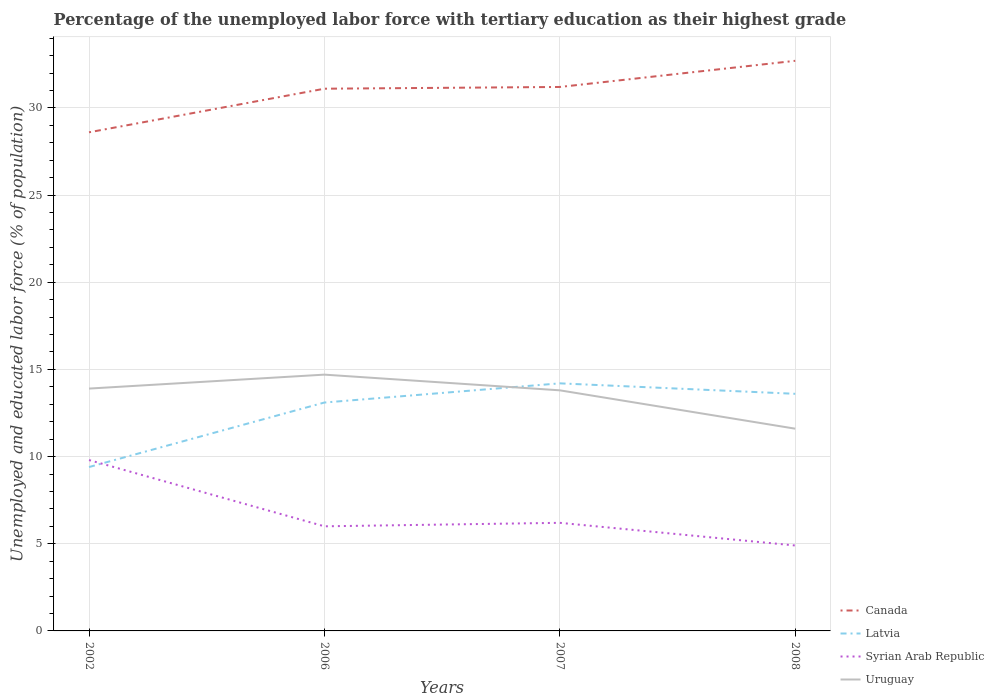How many different coloured lines are there?
Provide a short and direct response. 4. Across all years, what is the maximum percentage of the unemployed labor force with tertiary education in Latvia?
Ensure brevity in your answer.  9.4. What is the total percentage of the unemployed labor force with tertiary education in Canada in the graph?
Keep it short and to the point. -0.1. What is the difference between the highest and the second highest percentage of the unemployed labor force with tertiary education in Canada?
Your answer should be compact. 4.1. What is the difference between the highest and the lowest percentage of the unemployed labor force with tertiary education in Syrian Arab Republic?
Ensure brevity in your answer.  1. How many lines are there?
Offer a terse response. 4. How many years are there in the graph?
Offer a very short reply. 4. Are the values on the major ticks of Y-axis written in scientific E-notation?
Your response must be concise. No. Does the graph contain any zero values?
Offer a terse response. No. Where does the legend appear in the graph?
Your answer should be very brief. Bottom right. How many legend labels are there?
Provide a short and direct response. 4. How are the legend labels stacked?
Your response must be concise. Vertical. What is the title of the graph?
Give a very brief answer. Percentage of the unemployed labor force with tertiary education as their highest grade. Does "Micronesia" appear as one of the legend labels in the graph?
Your answer should be compact. No. What is the label or title of the Y-axis?
Provide a succinct answer. Unemployed and educated labor force (% of population). What is the Unemployed and educated labor force (% of population) in Canada in 2002?
Provide a short and direct response. 28.6. What is the Unemployed and educated labor force (% of population) in Latvia in 2002?
Offer a very short reply. 9.4. What is the Unemployed and educated labor force (% of population) in Syrian Arab Republic in 2002?
Provide a short and direct response. 9.8. What is the Unemployed and educated labor force (% of population) in Uruguay in 2002?
Your answer should be compact. 13.9. What is the Unemployed and educated labor force (% of population) of Canada in 2006?
Your answer should be very brief. 31.1. What is the Unemployed and educated labor force (% of population) of Latvia in 2006?
Provide a short and direct response. 13.1. What is the Unemployed and educated labor force (% of population) in Syrian Arab Republic in 2006?
Your answer should be very brief. 6. What is the Unemployed and educated labor force (% of population) in Uruguay in 2006?
Provide a short and direct response. 14.7. What is the Unemployed and educated labor force (% of population) in Canada in 2007?
Provide a succinct answer. 31.2. What is the Unemployed and educated labor force (% of population) in Latvia in 2007?
Make the answer very short. 14.2. What is the Unemployed and educated labor force (% of population) in Syrian Arab Republic in 2007?
Offer a terse response. 6.2. What is the Unemployed and educated labor force (% of population) in Uruguay in 2007?
Ensure brevity in your answer.  13.8. What is the Unemployed and educated labor force (% of population) of Canada in 2008?
Offer a terse response. 32.7. What is the Unemployed and educated labor force (% of population) of Latvia in 2008?
Give a very brief answer. 13.6. What is the Unemployed and educated labor force (% of population) in Syrian Arab Republic in 2008?
Offer a terse response. 4.9. What is the Unemployed and educated labor force (% of population) in Uruguay in 2008?
Provide a succinct answer. 11.6. Across all years, what is the maximum Unemployed and educated labor force (% of population) of Canada?
Keep it short and to the point. 32.7. Across all years, what is the maximum Unemployed and educated labor force (% of population) in Latvia?
Provide a short and direct response. 14.2. Across all years, what is the maximum Unemployed and educated labor force (% of population) of Syrian Arab Republic?
Offer a very short reply. 9.8. Across all years, what is the maximum Unemployed and educated labor force (% of population) of Uruguay?
Your answer should be compact. 14.7. Across all years, what is the minimum Unemployed and educated labor force (% of population) of Canada?
Keep it short and to the point. 28.6. Across all years, what is the minimum Unemployed and educated labor force (% of population) of Latvia?
Offer a very short reply. 9.4. Across all years, what is the minimum Unemployed and educated labor force (% of population) in Syrian Arab Republic?
Your answer should be compact. 4.9. Across all years, what is the minimum Unemployed and educated labor force (% of population) of Uruguay?
Your answer should be compact. 11.6. What is the total Unemployed and educated labor force (% of population) of Canada in the graph?
Ensure brevity in your answer.  123.6. What is the total Unemployed and educated labor force (% of population) in Latvia in the graph?
Offer a very short reply. 50.3. What is the total Unemployed and educated labor force (% of population) of Syrian Arab Republic in the graph?
Give a very brief answer. 26.9. What is the difference between the Unemployed and educated labor force (% of population) of Latvia in 2002 and that in 2006?
Provide a succinct answer. -3.7. What is the difference between the Unemployed and educated labor force (% of population) of Syrian Arab Republic in 2002 and that in 2006?
Provide a succinct answer. 3.8. What is the difference between the Unemployed and educated labor force (% of population) of Canada in 2002 and that in 2007?
Make the answer very short. -2.6. What is the difference between the Unemployed and educated labor force (% of population) in Syrian Arab Republic in 2002 and that in 2007?
Offer a terse response. 3.6. What is the difference between the Unemployed and educated labor force (% of population) in Latvia in 2002 and that in 2008?
Make the answer very short. -4.2. What is the difference between the Unemployed and educated labor force (% of population) in Uruguay in 2002 and that in 2008?
Offer a very short reply. 2.3. What is the difference between the Unemployed and educated labor force (% of population) of Canada in 2006 and that in 2008?
Offer a terse response. -1.6. What is the difference between the Unemployed and educated labor force (% of population) of Latvia in 2006 and that in 2008?
Offer a terse response. -0.5. What is the difference between the Unemployed and educated labor force (% of population) in Uruguay in 2006 and that in 2008?
Ensure brevity in your answer.  3.1. What is the difference between the Unemployed and educated labor force (% of population) in Latvia in 2007 and that in 2008?
Your answer should be compact. 0.6. What is the difference between the Unemployed and educated labor force (% of population) in Uruguay in 2007 and that in 2008?
Your answer should be compact. 2.2. What is the difference between the Unemployed and educated labor force (% of population) of Canada in 2002 and the Unemployed and educated labor force (% of population) of Latvia in 2006?
Your answer should be very brief. 15.5. What is the difference between the Unemployed and educated labor force (% of population) in Canada in 2002 and the Unemployed and educated labor force (% of population) in Syrian Arab Republic in 2006?
Your response must be concise. 22.6. What is the difference between the Unemployed and educated labor force (% of population) of Latvia in 2002 and the Unemployed and educated labor force (% of population) of Syrian Arab Republic in 2006?
Ensure brevity in your answer.  3.4. What is the difference between the Unemployed and educated labor force (% of population) in Syrian Arab Republic in 2002 and the Unemployed and educated labor force (% of population) in Uruguay in 2006?
Provide a succinct answer. -4.9. What is the difference between the Unemployed and educated labor force (% of population) of Canada in 2002 and the Unemployed and educated labor force (% of population) of Syrian Arab Republic in 2007?
Give a very brief answer. 22.4. What is the difference between the Unemployed and educated labor force (% of population) in Canada in 2002 and the Unemployed and educated labor force (% of population) in Uruguay in 2007?
Make the answer very short. 14.8. What is the difference between the Unemployed and educated labor force (% of population) of Latvia in 2002 and the Unemployed and educated labor force (% of population) of Syrian Arab Republic in 2007?
Your response must be concise. 3.2. What is the difference between the Unemployed and educated labor force (% of population) of Syrian Arab Republic in 2002 and the Unemployed and educated labor force (% of population) of Uruguay in 2007?
Ensure brevity in your answer.  -4. What is the difference between the Unemployed and educated labor force (% of population) of Canada in 2002 and the Unemployed and educated labor force (% of population) of Syrian Arab Republic in 2008?
Provide a succinct answer. 23.7. What is the difference between the Unemployed and educated labor force (% of population) of Canada in 2006 and the Unemployed and educated labor force (% of population) of Latvia in 2007?
Offer a terse response. 16.9. What is the difference between the Unemployed and educated labor force (% of population) in Canada in 2006 and the Unemployed and educated labor force (% of population) in Syrian Arab Republic in 2007?
Offer a very short reply. 24.9. What is the difference between the Unemployed and educated labor force (% of population) of Canada in 2006 and the Unemployed and educated labor force (% of population) of Uruguay in 2007?
Give a very brief answer. 17.3. What is the difference between the Unemployed and educated labor force (% of population) in Latvia in 2006 and the Unemployed and educated labor force (% of population) in Syrian Arab Republic in 2007?
Your answer should be very brief. 6.9. What is the difference between the Unemployed and educated labor force (% of population) of Latvia in 2006 and the Unemployed and educated labor force (% of population) of Uruguay in 2007?
Offer a very short reply. -0.7. What is the difference between the Unemployed and educated labor force (% of population) of Syrian Arab Republic in 2006 and the Unemployed and educated labor force (% of population) of Uruguay in 2007?
Your answer should be very brief. -7.8. What is the difference between the Unemployed and educated labor force (% of population) of Canada in 2006 and the Unemployed and educated labor force (% of population) of Syrian Arab Republic in 2008?
Your answer should be very brief. 26.2. What is the difference between the Unemployed and educated labor force (% of population) of Syrian Arab Republic in 2006 and the Unemployed and educated labor force (% of population) of Uruguay in 2008?
Keep it short and to the point. -5.6. What is the difference between the Unemployed and educated labor force (% of population) of Canada in 2007 and the Unemployed and educated labor force (% of population) of Latvia in 2008?
Give a very brief answer. 17.6. What is the difference between the Unemployed and educated labor force (% of population) in Canada in 2007 and the Unemployed and educated labor force (% of population) in Syrian Arab Republic in 2008?
Provide a succinct answer. 26.3. What is the difference between the Unemployed and educated labor force (% of population) of Canada in 2007 and the Unemployed and educated labor force (% of population) of Uruguay in 2008?
Make the answer very short. 19.6. What is the average Unemployed and educated labor force (% of population) in Canada per year?
Your response must be concise. 30.9. What is the average Unemployed and educated labor force (% of population) of Latvia per year?
Provide a short and direct response. 12.57. What is the average Unemployed and educated labor force (% of population) in Syrian Arab Republic per year?
Offer a very short reply. 6.72. In the year 2002, what is the difference between the Unemployed and educated labor force (% of population) in Canada and Unemployed and educated labor force (% of population) in Uruguay?
Provide a short and direct response. 14.7. In the year 2002, what is the difference between the Unemployed and educated labor force (% of population) in Syrian Arab Republic and Unemployed and educated labor force (% of population) in Uruguay?
Ensure brevity in your answer.  -4.1. In the year 2006, what is the difference between the Unemployed and educated labor force (% of population) in Canada and Unemployed and educated labor force (% of population) in Latvia?
Ensure brevity in your answer.  18. In the year 2006, what is the difference between the Unemployed and educated labor force (% of population) in Canada and Unemployed and educated labor force (% of population) in Syrian Arab Republic?
Provide a succinct answer. 25.1. In the year 2006, what is the difference between the Unemployed and educated labor force (% of population) in Canada and Unemployed and educated labor force (% of population) in Uruguay?
Offer a very short reply. 16.4. In the year 2007, what is the difference between the Unemployed and educated labor force (% of population) in Canada and Unemployed and educated labor force (% of population) in Latvia?
Ensure brevity in your answer.  17. In the year 2007, what is the difference between the Unemployed and educated labor force (% of population) in Canada and Unemployed and educated labor force (% of population) in Syrian Arab Republic?
Offer a terse response. 25. In the year 2007, what is the difference between the Unemployed and educated labor force (% of population) in Latvia and Unemployed and educated labor force (% of population) in Uruguay?
Give a very brief answer. 0.4. In the year 2007, what is the difference between the Unemployed and educated labor force (% of population) of Syrian Arab Republic and Unemployed and educated labor force (% of population) of Uruguay?
Ensure brevity in your answer.  -7.6. In the year 2008, what is the difference between the Unemployed and educated labor force (% of population) of Canada and Unemployed and educated labor force (% of population) of Latvia?
Ensure brevity in your answer.  19.1. In the year 2008, what is the difference between the Unemployed and educated labor force (% of population) in Canada and Unemployed and educated labor force (% of population) in Syrian Arab Republic?
Offer a very short reply. 27.8. In the year 2008, what is the difference between the Unemployed and educated labor force (% of population) in Canada and Unemployed and educated labor force (% of population) in Uruguay?
Give a very brief answer. 21.1. In the year 2008, what is the difference between the Unemployed and educated labor force (% of population) in Latvia and Unemployed and educated labor force (% of population) in Syrian Arab Republic?
Your answer should be compact. 8.7. In the year 2008, what is the difference between the Unemployed and educated labor force (% of population) of Syrian Arab Republic and Unemployed and educated labor force (% of population) of Uruguay?
Your answer should be compact. -6.7. What is the ratio of the Unemployed and educated labor force (% of population) in Canada in 2002 to that in 2006?
Your answer should be very brief. 0.92. What is the ratio of the Unemployed and educated labor force (% of population) in Latvia in 2002 to that in 2006?
Provide a succinct answer. 0.72. What is the ratio of the Unemployed and educated labor force (% of population) of Syrian Arab Republic in 2002 to that in 2006?
Keep it short and to the point. 1.63. What is the ratio of the Unemployed and educated labor force (% of population) of Uruguay in 2002 to that in 2006?
Make the answer very short. 0.95. What is the ratio of the Unemployed and educated labor force (% of population) of Canada in 2002 to that in 2007?
Provide a short and direct response. 0.92. What is the ratio of the Unemployed and educated labor force (% of population) in Latvia in 2002 to that in 2007?
Your answer should be very brief. 0.66. What is the ratio of the Unemployed and educated labor force (% of population) in Syrian Arab Republic in 2002 to that in 2007?
Provide a succinct answer. 1.58. What is the ratio of the Unemployed and educated labor force (% of population) of Uruguay in 2002 to that in 2007?
Your response must be concise. 1.01. What is the ratio of the Unemployed and educated labor force (% of population) in Canada in 2002 to that in 2008?
Make the answer very short. 0.87. What is the ratio of the Unemployed and educated labor force (% of population) of Latvia in 2002 to that in 2008?
Your answer should be compact. 0.69. What is the ratio of the Unemployed and educated labor force (% of population) in Uruguay in 2002 to that in 2008?
Offer a very short reply. 1.2. What is the ratio of the Unemployed and educated labor force (% of population) in Latvia in 2006 to that in 2007?
Provide a short and direct response. 0.92. What is the ratio of the Unemployed and educated labor force (% of population) in Syrian Arab Republic in 2006 to that in 2007?
Offer a very short reply. 0.97. What is the ratio of the Unemployed and educated labor force (% of population) in Uruguay in 2006 to that in 2007?
Provide a short and direct response. 1.07. What is the ratio of the Unemployed and educated labor force (% of population) of Canada in 2006 to that in 2008?
Your response must be concise. 0.95. What is the ratio of the Unemployed and educated labor force (% of population) in Latvia in 2006 to that in 2008?
Your answer should be very brief. 0.96. What is the ratio of the Unemployed and educated labor force (% of population) of Syrian Arab Republic in 2006 to that in 2008?
Keep it short and to the point. 1.22. What is the ratio of the Unemployed and educated labor force (% of population) of Uruguay in 2006 to that in 2008?
Offer a terse response. 1.27. What is the ratio of the Unemployed and educated labor force (% of population) in Canada in 2007 to that in 2008?
Your answer should be compact. 0.95. What is the ratio of the Unemployed and educated labor force (% of population) of Latvia in 2007 to that in 2008?
Offer a terse response. 1.04. What is the ratio of the Unemployed and educated labor force (% of population) in Syrian Arab Republic in 2007 to that in 2008?
Provide a succinct answer. 1.27. What is the ratio of the Unemployed and educated labor force (% of population) in Uruguay in 2007 to that in 2008?
Your response must be concise. 1.19. What is the difference between the highest and the second highest Unemployed and educated labor force (% of population) in Canada?
Provide a succinct answer. 1.5. What is the difference between the highest and the lowest Unemployed and educated labor force (% of population) of Latvia?
Offer a very short reply. 4.8. What is the difference between the highest and the lowest Unemployed and educated labor force (% of population) in Uruguay?
Your answer should be compact. 3.1. 